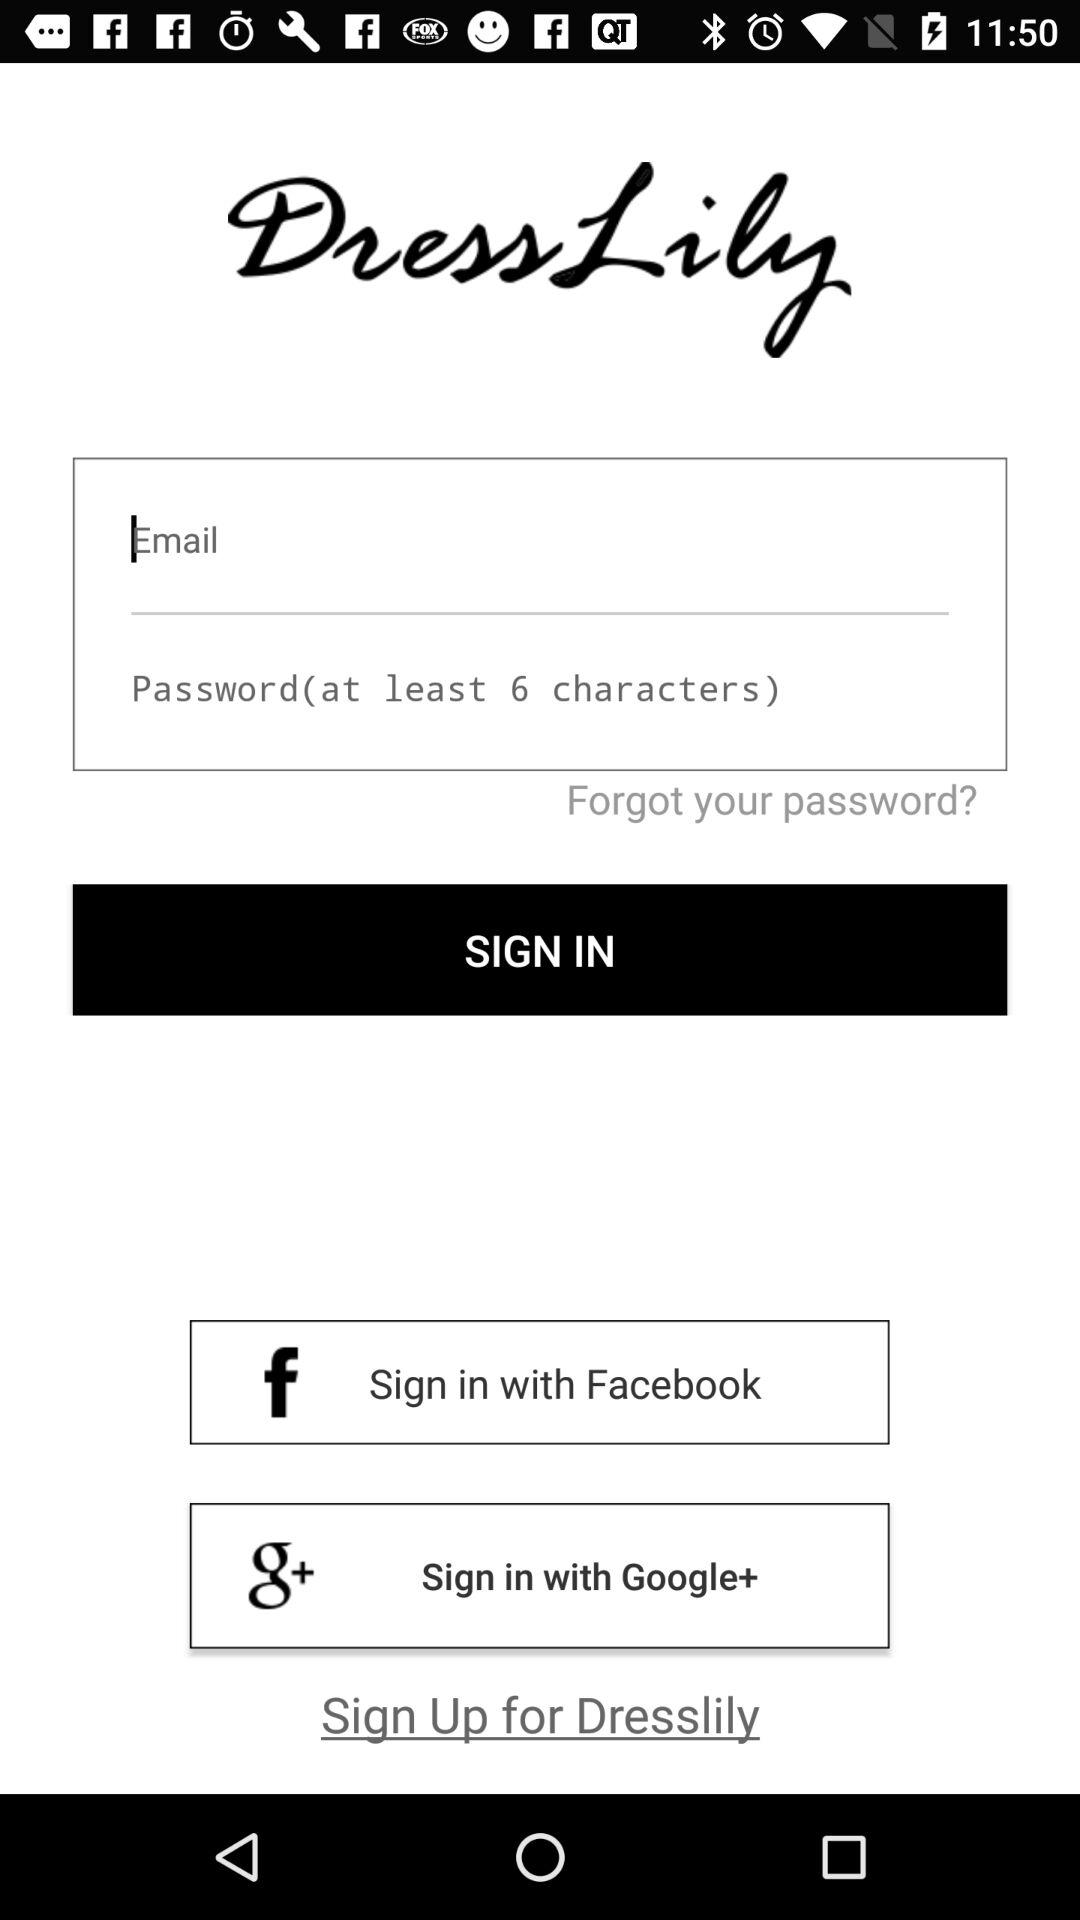How many social media login options are there?
Answer the question using a single word or phrase. 2 